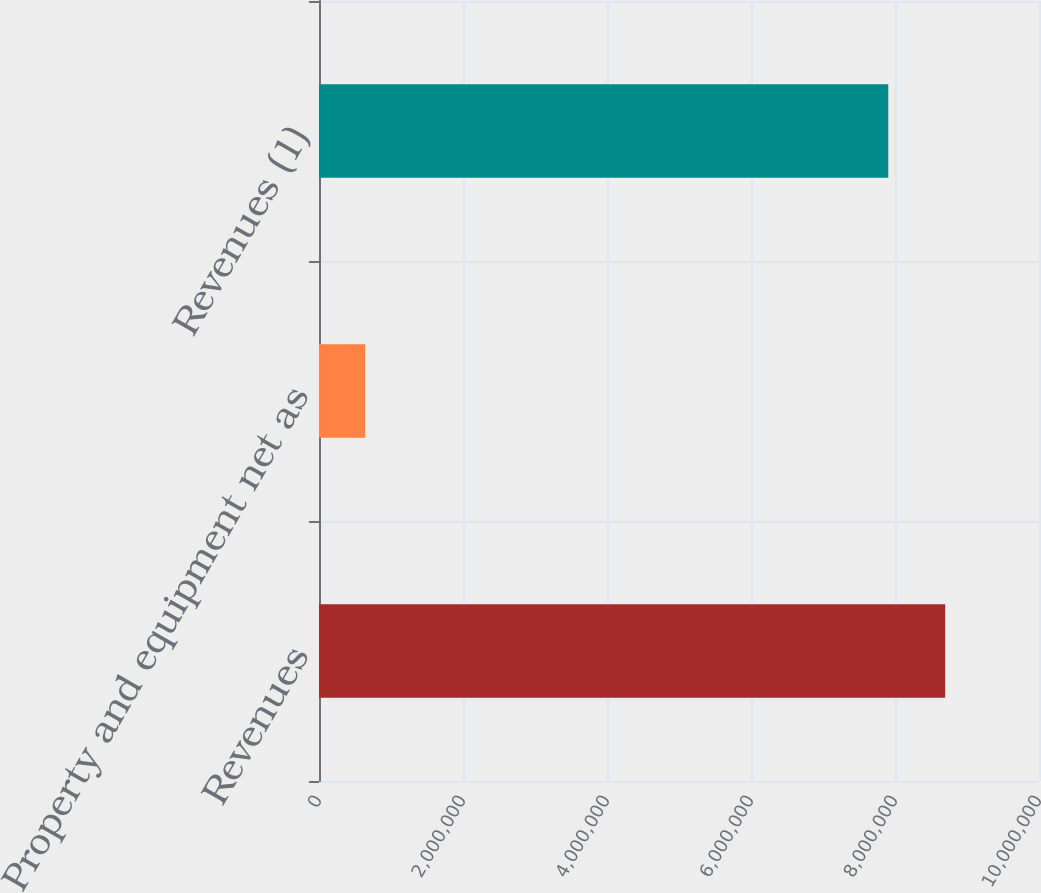Convert chart. <chart><loc_0><loc_0><loc_500><loc_500><bar_chart><fcel>Revenues<fcel>Property and equipment net as<fcel>Revenues (1)<nl><fcel>8.69708e+06<fcel>641022<fcel>7.90637e+06<nl></chart> 